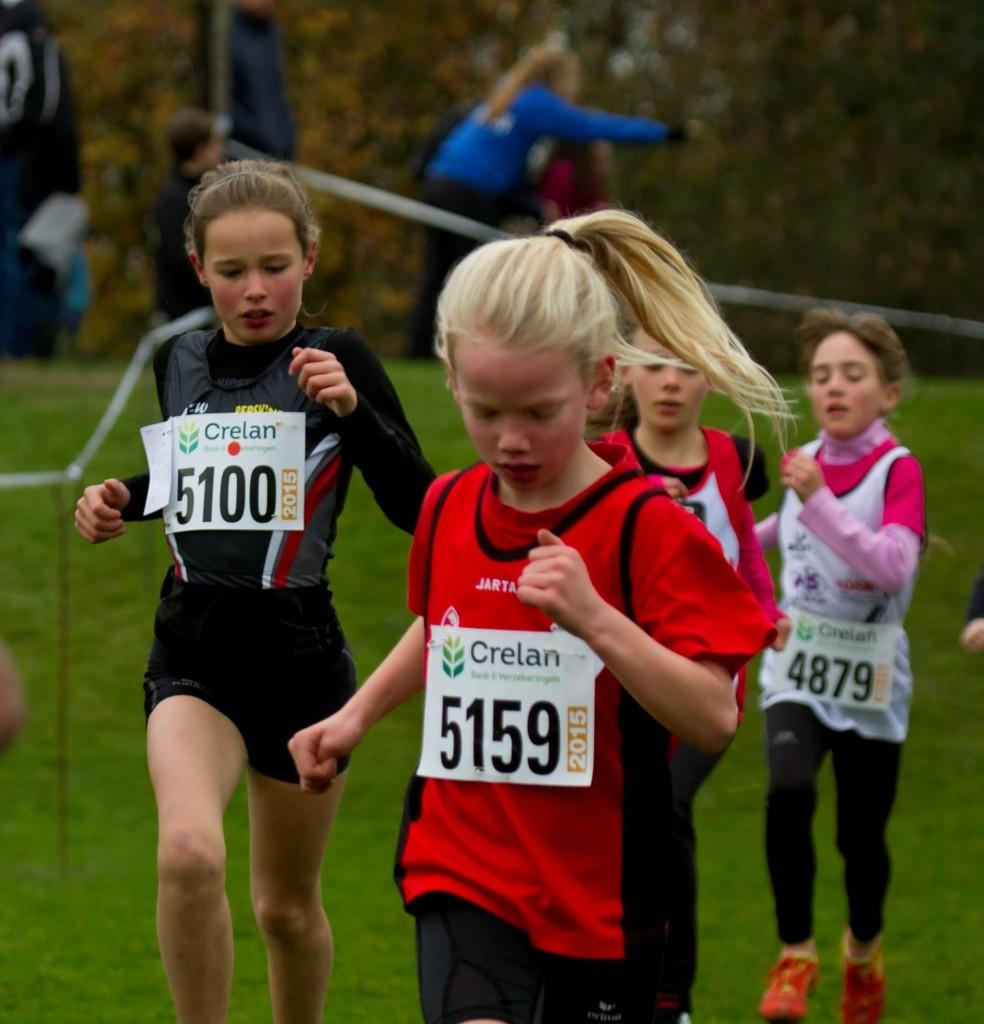How many girls are present in the image? There are four small girls in the image. What are the girls wearing? The girls are wearing red and black t-shirts. What activity are the girls engaged in? The girls are running in the grass ground. Can you describe the background of the image? The background of the image is blurred. What type of honey can be seen dripping from the lizards in the image? There are no lizards or honey present in the image; it features four small girls running in the grass. 